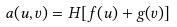Convert formula to latex. <formula><loc_0><loc_0><loc_500><loc_500>a ( u , v ) = H [ f ( u ) + g ( v ) ]</formula> 